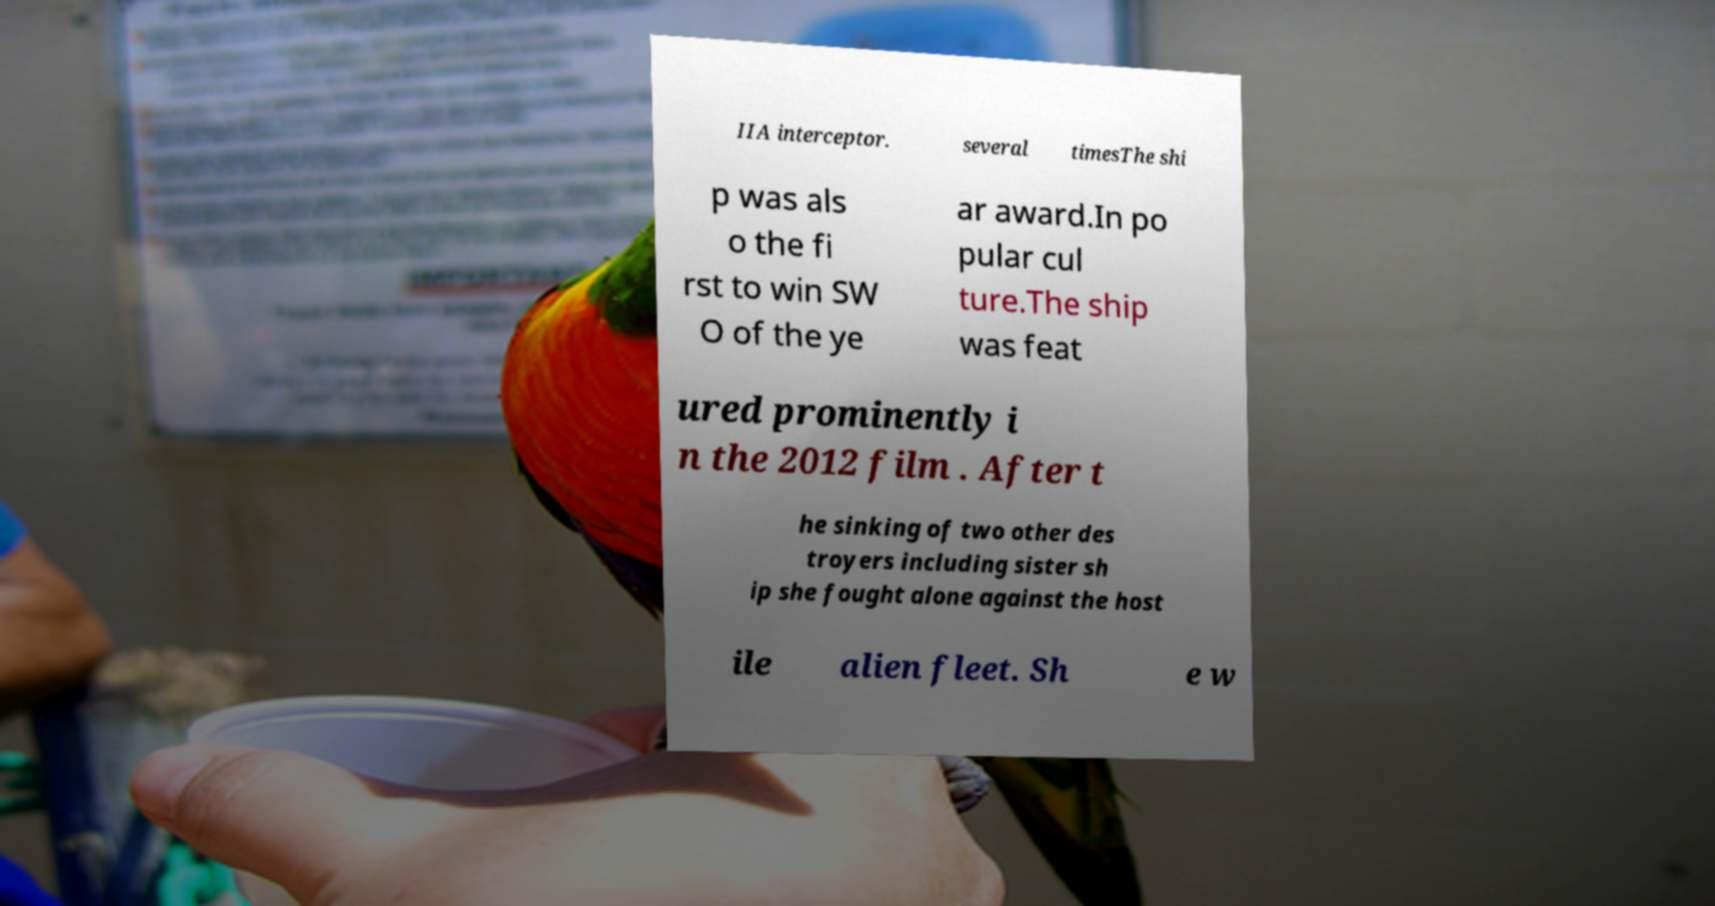Can you read and provide the text displayed in the image?This photo seems to have some interesting text. Can you extract and type it out for me? IIA interceptor. several timesThe shi p was als o the fi rst to win SW O of the ye ar award.In po pular cul ture.The ship was feat ured prominently i n the 2012 film . After t he sinking of two other des troyers including sister sh ip she fought alone against the host ile alien fleet. Sh e w 